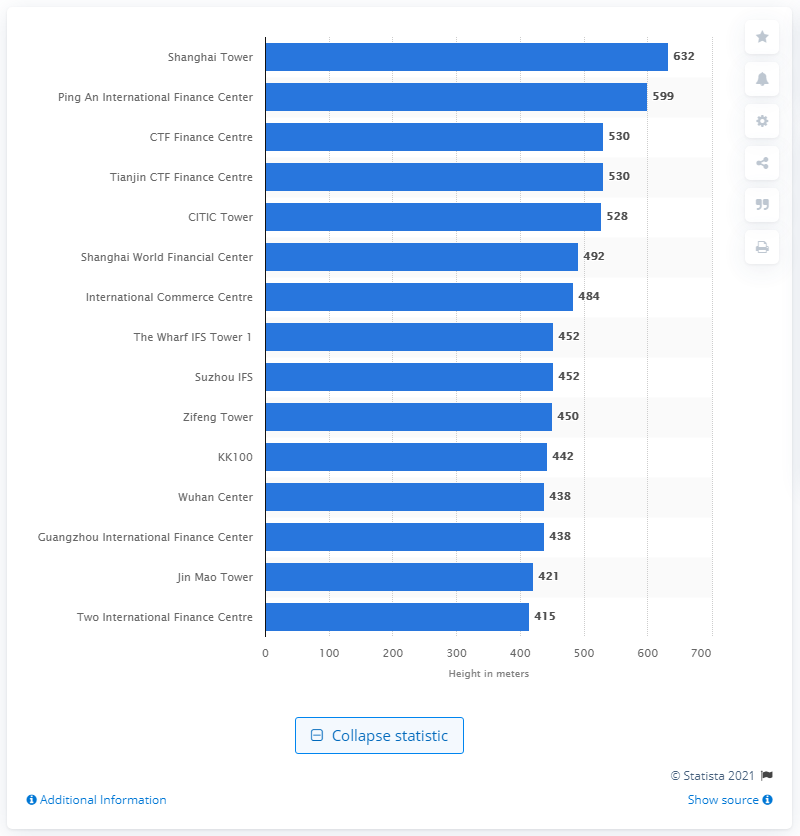Mention a couple of crucial points in this snapshot. The Shanghai Tower is the tallest completed skyscraper in China, standing at a height of approximately 2,073 feet. 